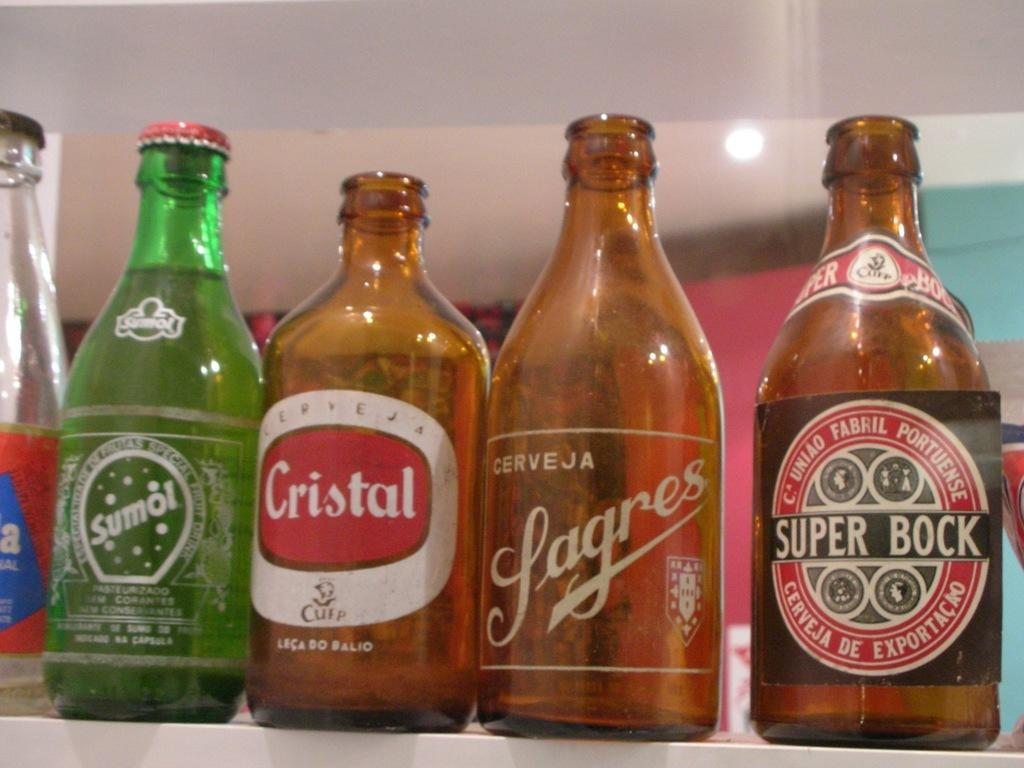<image>
Present a compact description of the photo's key features. Four small bottles of various kinds of beer which one is labeled Super Block. 